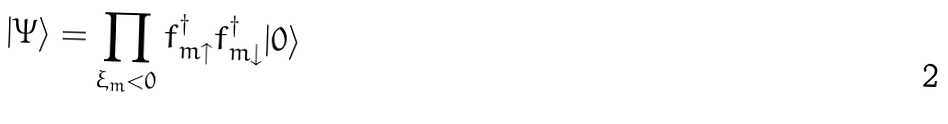Convert formula to latex. <formula><loc_0><loc_0><loc_500><loc_500>| \Psi \rangle = \prod _ { \xi _ { m } < 0 } f _ { m \uparrow } ^ { \dagger } f _ { m \downarrow } ^ { \dagger } | 0 \rangle</formula> 